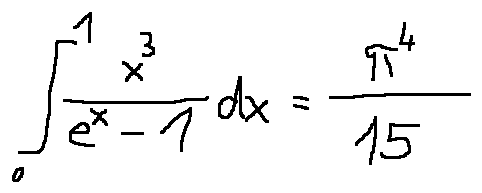<formula> <loc_0><loc_0><loc_500><loc_500>\int \lim i t s _ { 0 } ^ { 1 } \frac { x ^ { 3 } } { e ^ { x } - 1 } d x = \frac { \pi ^ { 4 } } { 1 5 }</formula> 